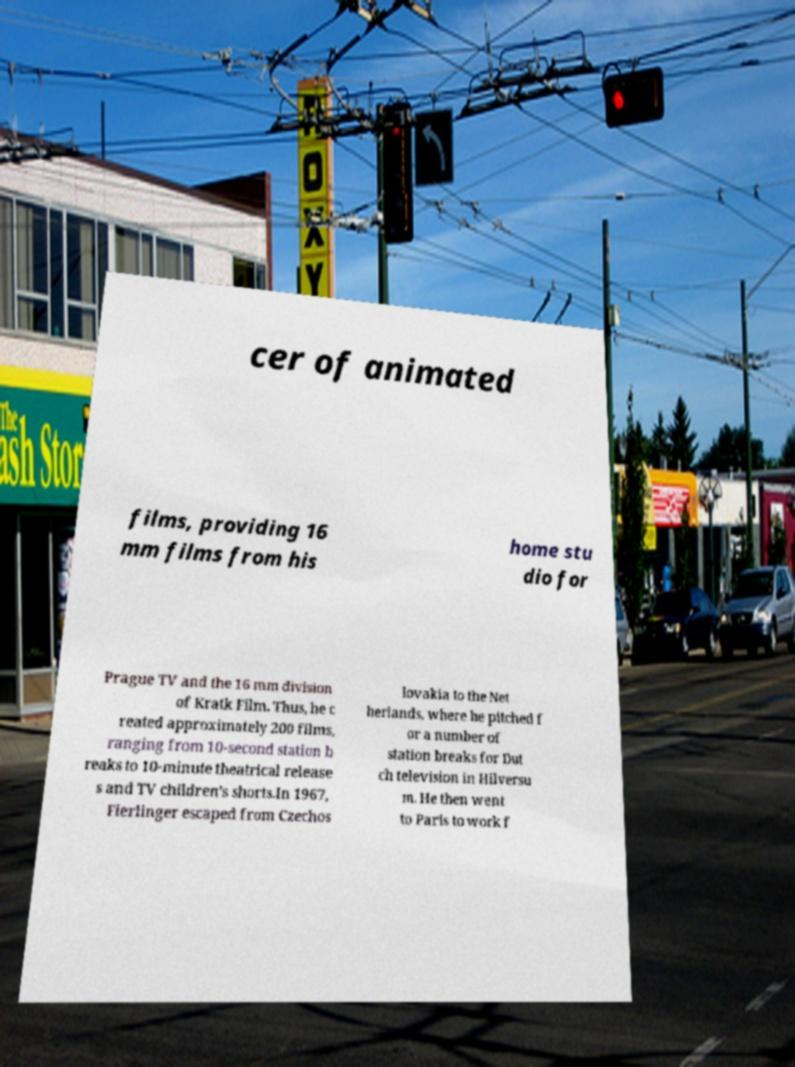For documentation purposes, I need the text within this image transcribed. Could you provide that? cer of animated films, providing 16 mm films from his home stu dio for Prague TV and the 16 mm division of Kratk Film. Thus, he c reated approximately 200 films, ranging from 10-second station b reaks to 10-minute theatrical release s and TV children’s shorts.In 1967, Fierlinger escaped from Czechos lovakia to the Net herlands, where he pitched f or a number of station breaks for Dut ch television in Hilversu m. He then went to Paris to work f 